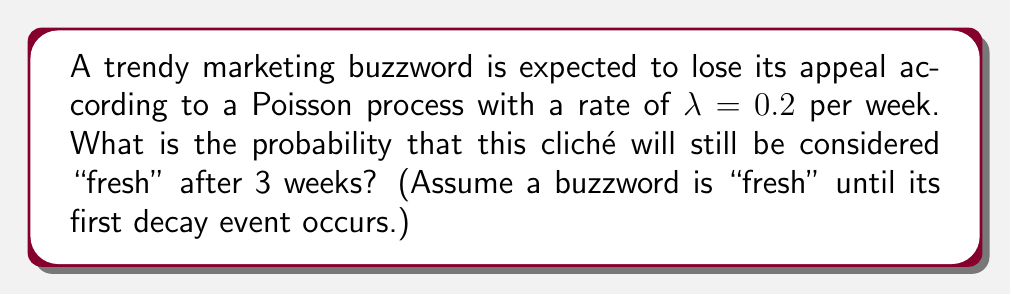Give your solution to this math problem. Let's approach this step-by-step:

1) In a Poisson process, the time until the first event (in this case, the decay of the buzzword) follows an exponential distribution with the same rate parameter $\lambda$.

2) The probability that the time until the first event (T) is greater than some time t is given by:

   $$P(T > t) = e^{-\lambda t}$$

3) In this case, we want to find $P(T > 3)$ with $\lambda = 0.2$:

   $$P(T > 3) = e^{-0.2 * 3}$$

4) Let's calculate this:

   $$P(T > 3) = e^{-0.6}$$

5) Using a calculator or mathematical software:

   $$P(T > 3) \approx 0.5488$$

6) Therefore, the probability that the buzzword will still be "fresh" after 3 weeks is approximately 0.5488 or about 54.88%.

This result suggests that overused marketing jargon has about a 55% chance of still being considered trendy after 3 weeks, which might be longer than a savvy copywriter would expect!
Answer: $e^{-0.6} \approx 0.5488$ 